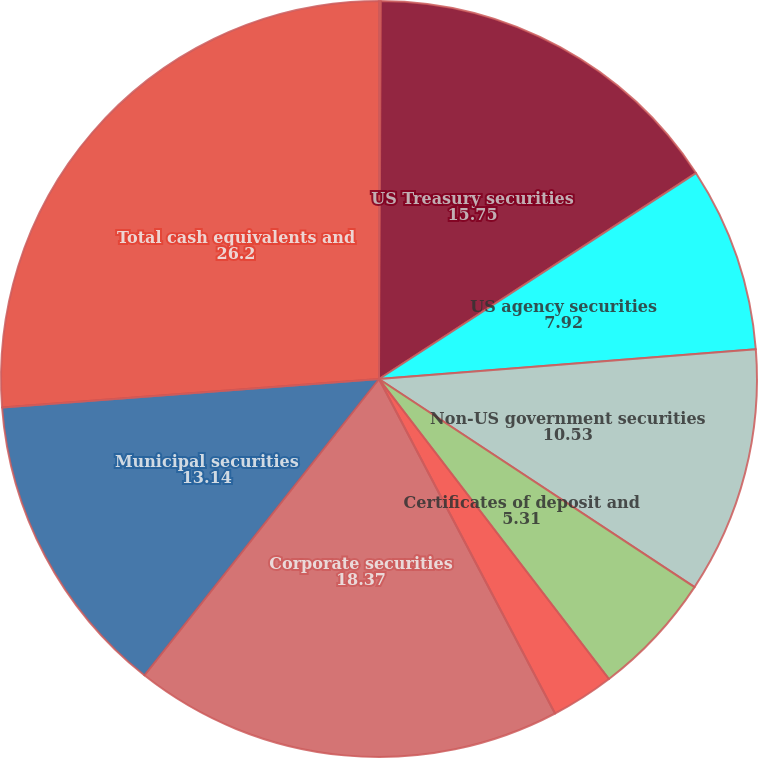<chart> <loc_0><loc_0><loc_500><loc_500><pie_chart><fcel>Money market funds<fcel>US Treasury securities<fcel>US agency securities<fcel>Non-US government securities<fcel>Certificates of deposit and<fcel>Commercial paper<fcel>Corporate securities<fcel>Municipal securities<fcel>Total cash equivalents and<nl><fcel>0.08%<fcel>15.75%<fcel>7.92%<fcel>10.53%<fcel>5.31%<fcel>2.7%<fcel>18.37%<fcel>13.14%<fcel>26.2%<nl></chart> 